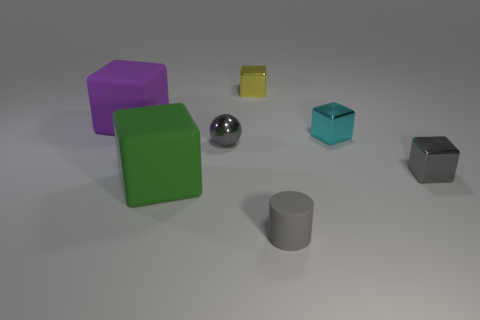What is the shape of the tiny rubber object that is the same color as the metal ball?
Offer a terse response. Cylinder. There is a tiny cylinder that is the same color as the tiny metal sphere; what is its material?
Ensure brevity in your answer.  Rubber. Is the material of the small thing to the left of the yellow block the same as the small cube that is to the right of the tiny cyan metal cube?
Your answer should be very brief. Yes. What is the material of the yellow block?
Your answer should be compact. Metal. How many other things are there of the same color as the small metal ball?
Your response must be concise. 2. Is the color of the ball the same as the cylinder?
Your answer should be compact. Yes. How many small yellow matte cylinders are there?
Provide a short and direct response. 0. There is a tiny gray object that is left of the small object in front of the green block; what is its material?
Give a very brief answer. Metal. There is a gray block that is the same size as the sphere; what material is it?
Your response must be concise. Metal. There is a matte cube that is in front of the purple rubber thing; is it the same size as the tiny gray sphere?
Your response must be concise. No. 